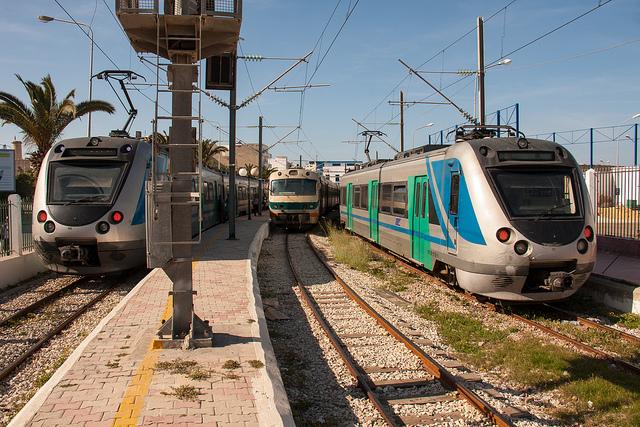How many trains are in this picture?
Short answer required. 3. Are the trains featured in this picture in motion?
Answer briefly. No. How many trains are there?
Quick response, please. 3. Is the sky clear?
Keep it brief. Yes. Are these trains powered electrically?
Write a very short answer. Yes. 